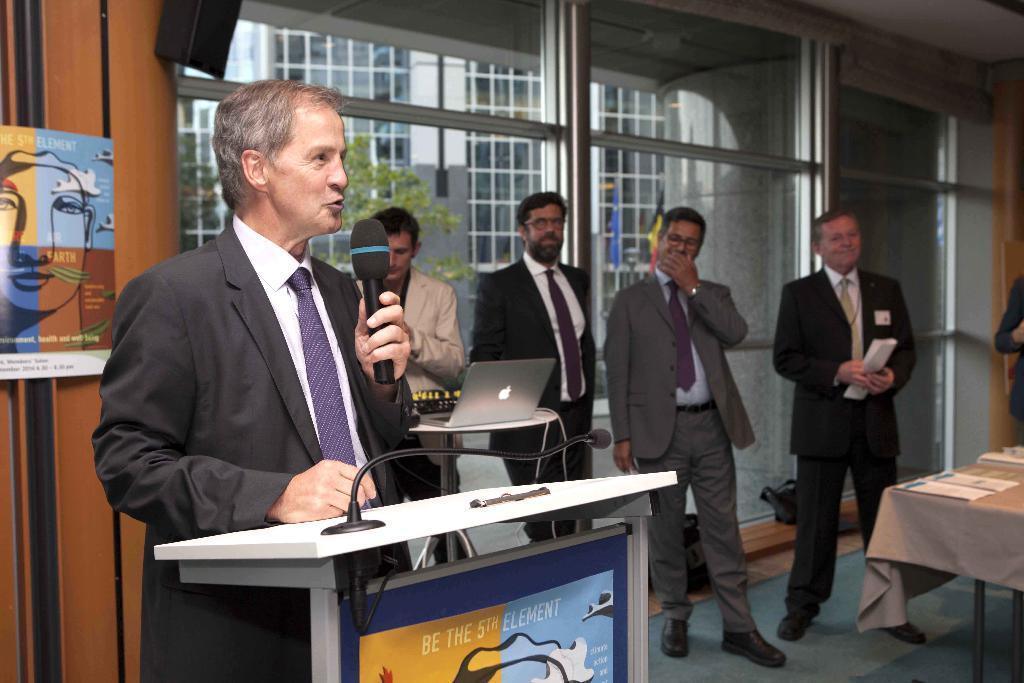Describe this image in one or two sentences. In this image, we can see persons wearing clothes and standing in front of the window. There is a person on the left side of the image standing in front of the table and holding a mic with his hand. There is a laptop on the table which is in the middle of the image. There is an another table in the bottom right of the image covered with a cloth. 